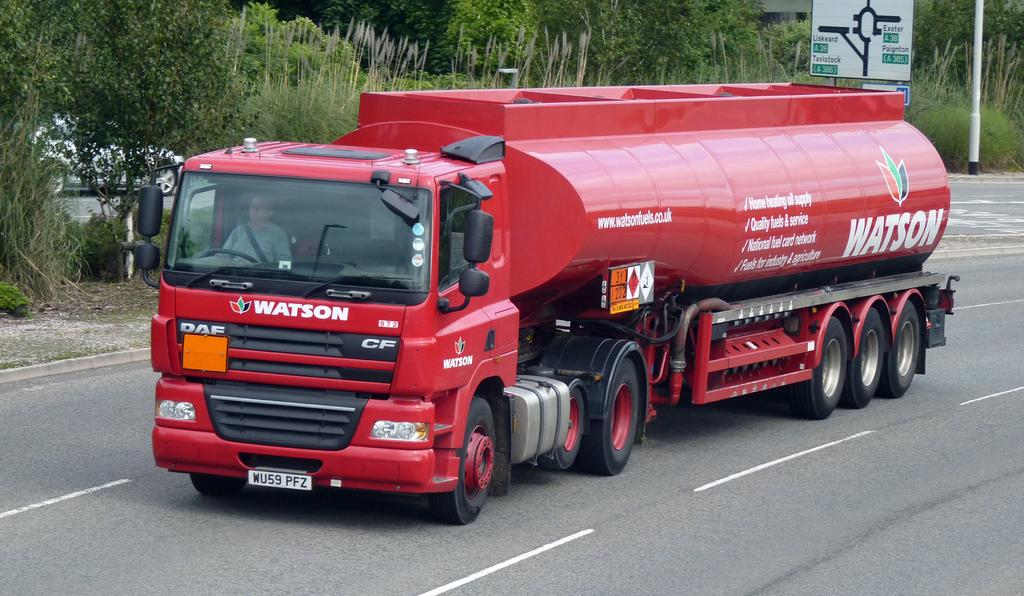What is on the road in the image? There is a vehicle on the road in the image. Who is inside the vehicle? A man is inside the vehicle. What can be seen in the background of the image? There are trees and boards on poles in the background. Are there any other vehicles visible in the image? Yes, there is a car in the background. How many toothbrushes are visible in the image? There are no toothbrushes present in the image. What type of eggs can be seen in the image? There are no eggs present in the image. 